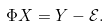<formula> <loc_0><loc_0><loc_500><loc_500>\Phi X = Y - \mathcal { E } .</formula> 